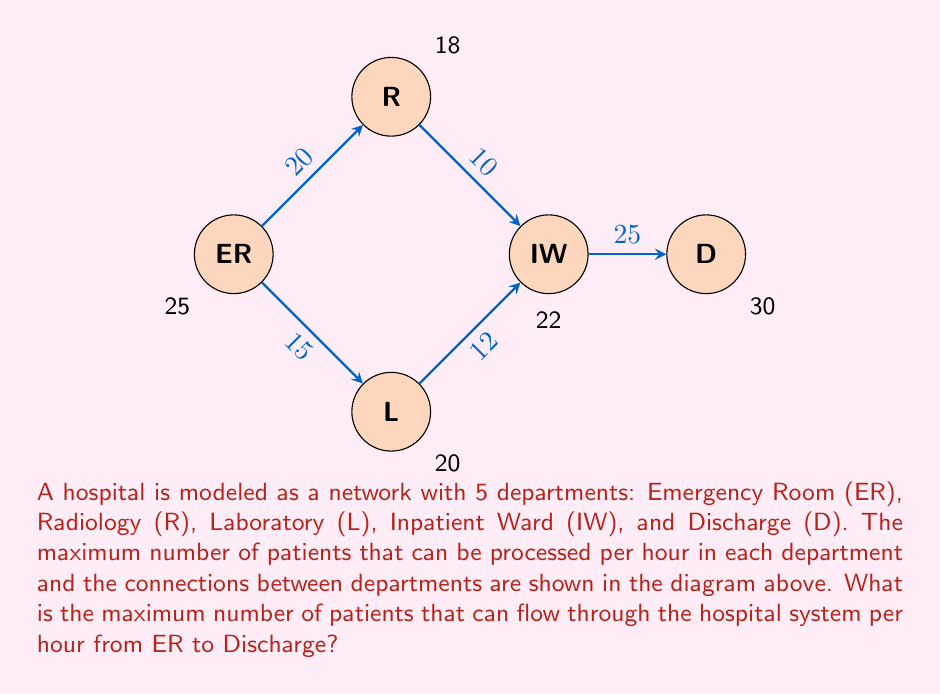Help me with this question. To solve this problem, we need to use the max-flow min-cut theorem from network flow theory. This theorem states that the maximum flow through a network is equal to the capacity of the minimum cut in the network.

Let's approach this step-by-step:

1) First, we need to identify all possible paths from ER to D:
   - ER → R → IW → D
   - ER → L → IW → D

2) Now, let's look at the bottlenecks in each path:
   - For ER → R → IW → D: min(20, 18, 10, 22, 25) = 10
   - For ER → L → IW → D: min(15, 20, 12, 22, 25) = 12

3) The sum of these bottlenecks gives us a lower bound for the maximum flow: 10 + 12 = 22

4) However, we need to check if the IW department can handle this flow:
   The total flow into IW is 22, which is exactly its capacity. This means IW is the bottleneck for the entire system.

5) We also need to check the capacity of ER:
   The total outflow from ER is 20 + 15 = 35, which is more than its capacity of 25. This means ER is also a bottleneck.

6) The minimum of these two bottlenecks (ER and IW) will give us the maximum flow:
   min(25, 22) = 22

Therefore, the maximum number of patients that can flow through the hospital system per hour is 22.

This problem illustrates how network flow algorithms can be used to optimize patient flow in hospitals, a stark contrast to historical practices where such quantitative methods were not available to healthcare practitioners.
Answer: 22 patients per hour 